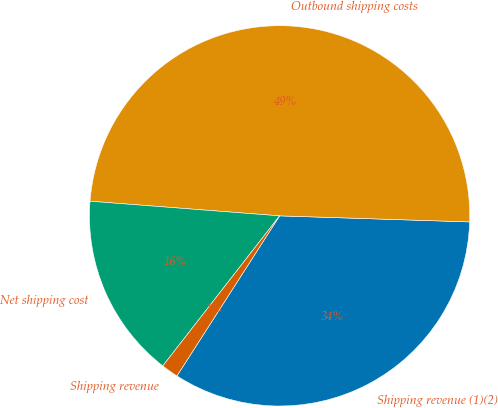<chart> <loc_0><loc_0><loc_500><loc_500><pie_chart><fcel>Shipping revenue (1)(2)<fcel>Outbound shipping costs<fcel>Net shipping cost<fcel>Shipping revenue<nl><fcel>33.57%<fcel>49.28%<fcel>15.7%<fcel>1.45%<nl></chart> 